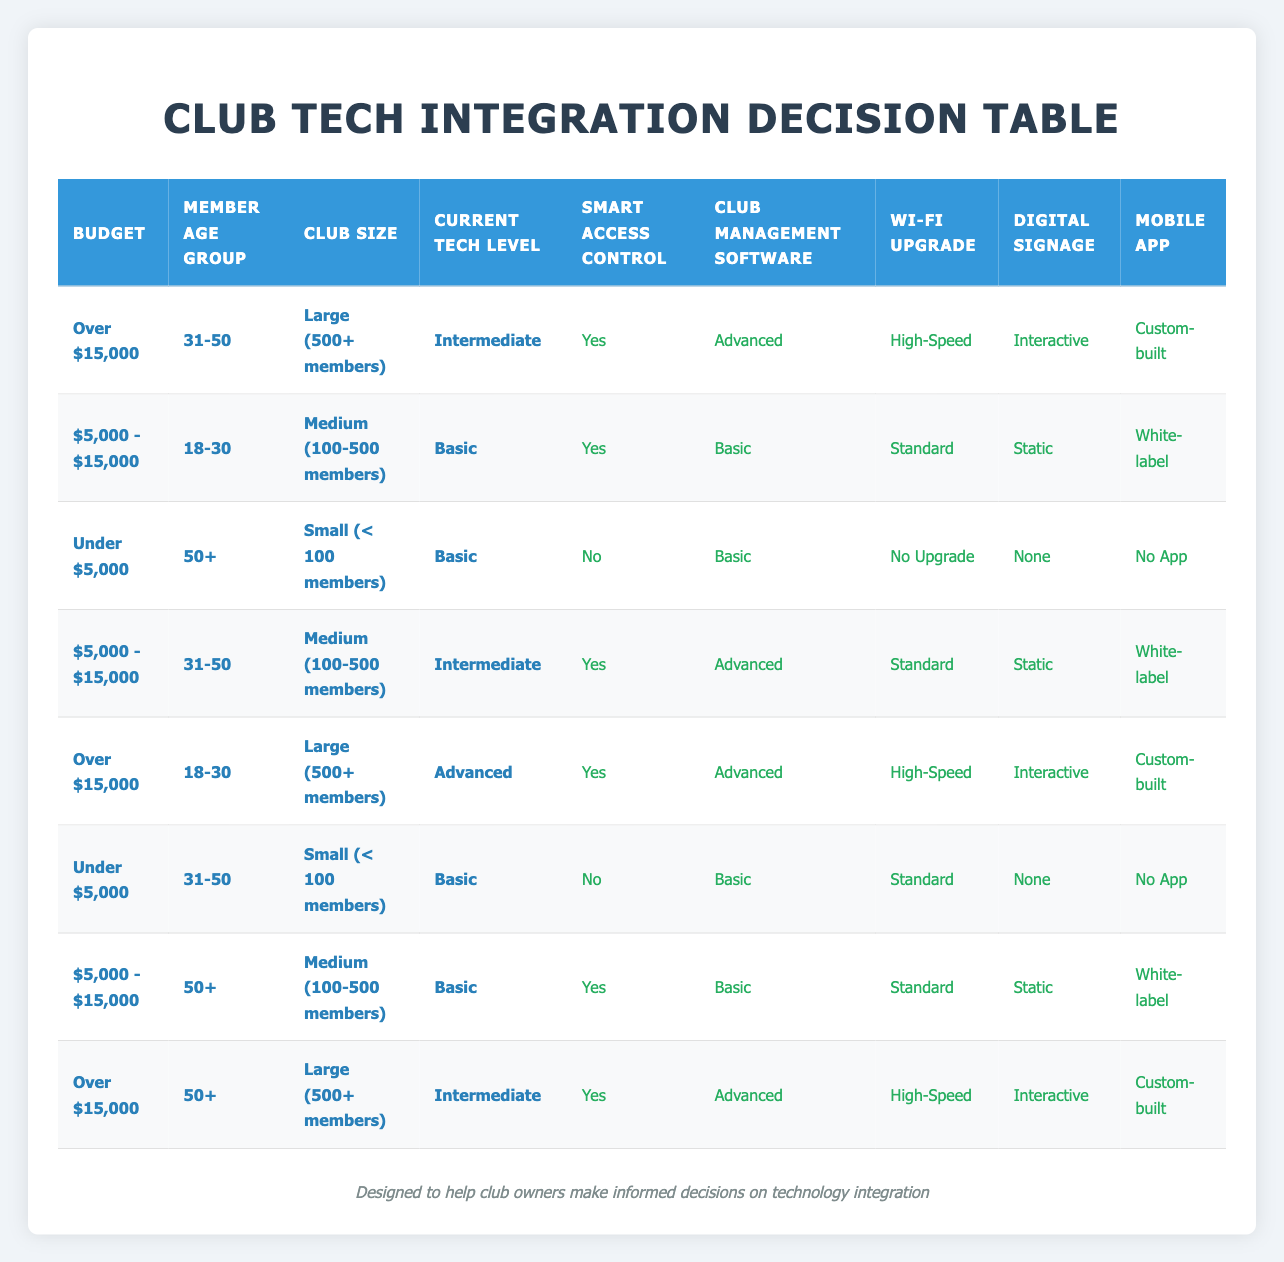What actions are taken for a budget over $15,000 with members aged 31-50 in a large club with intermediate tech levels? The table shows that for a budget of over $15,000, a member age group of 31-50, and a large club with intermediate tech levels, the actions taken are: Install Smart Access Control System (Yes), Implement Club Management Software (Advanced), Upgrade Wi-Fi Infrastructure (High-Speed), Add Digital Signage (Interactive), and Introduce Mobile App (Custom-built).
Answer: Yes, Advanced, High-Speed, Interactive, Custom-built Is there a case where no app is introduced based on the budget? Scanning the table, I found that in two scenarios corresponding to budget conditions, a mobile app is not introduced: first, under $5,000 for the age group 50+ in a small club; second, under $5,000 for the age group 31-50 in a small club. Therefore, it is confirmed that there are cases with no app.
Answer: Yes What is the total number of action options listed for the age group 50+ and budget between $5,000 and $15,000? In the relevant row for the age group 50+ with a budget of $5,000 - $15,000, there are five action options listed: Yes for Smart Access Control System, Basic for Club Management Software, Standard for Wi-Fi upgrade, Static for Digital Signage, and White-label for Mobile App. Summing these options gives a total of 5 actions.
Answer: 5 What type of Wi-Fi upgrade is recommended for clubs that fall under a budget of $5,000 and have basic tech levels with members aged 31-50? Referring to the table, for a budget of under $5,000, member age group 31-50, and basic tech levels, the Wi-Fi infrastructure recommendation is 'Standard.'
Answer: Standard How many action options are categorized as 'Interactive' for clubs with a large size in the budget range over $15,000? Looking through the rows, I see that there are two instances with the budget over $15,000 and a club size category of large: one for the age group 31-50 (where the signage is Interactive) and the other for the age group 18-30 (also with Interactive signage). Thus, there are two action options categorized as 'Interactive.'
Answer: 2 